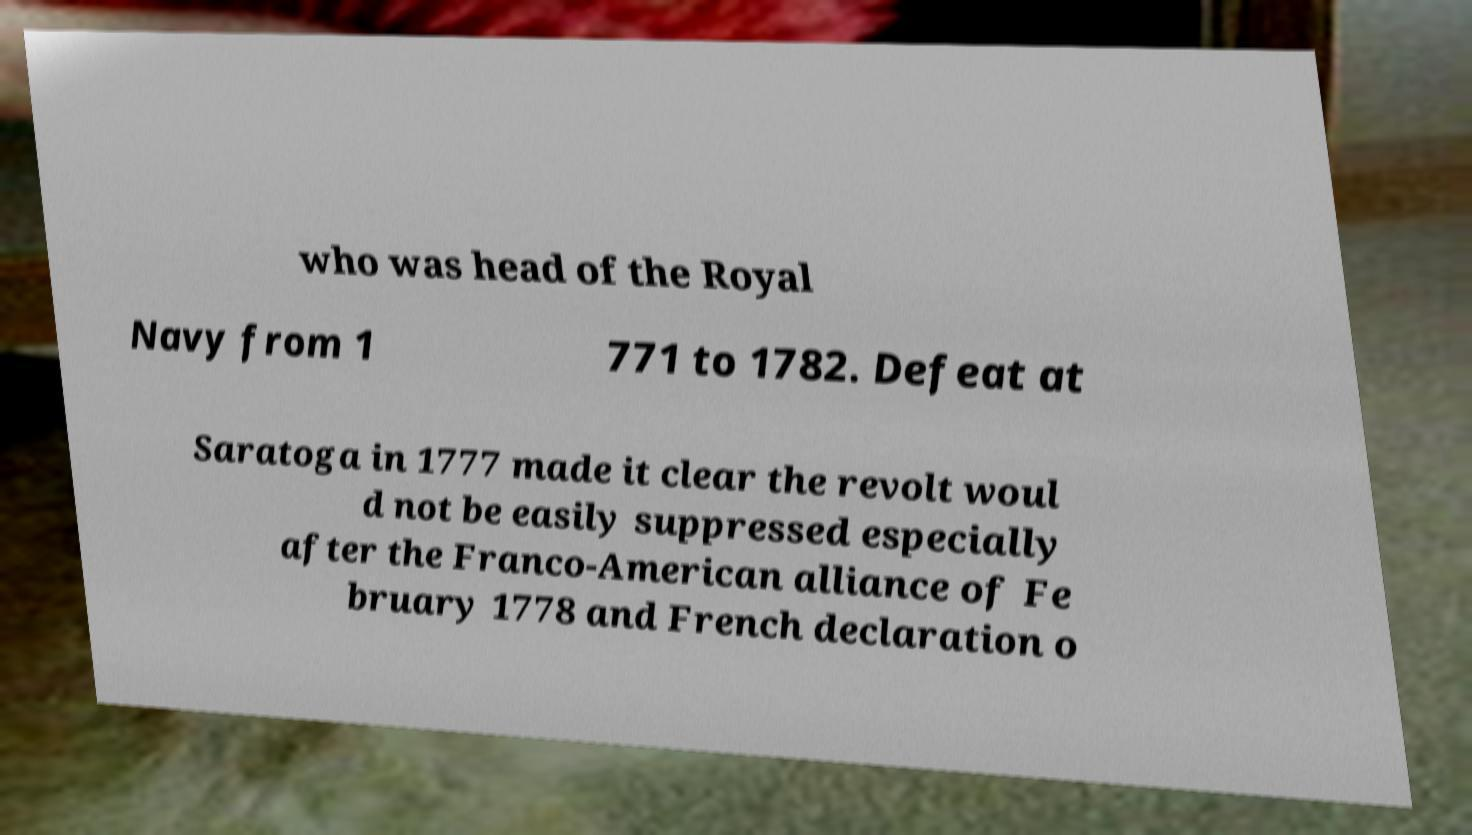Please identify and transcribe the text found in this image. who was head of the Royal Navy from 1 771 to 1782. Defeat at Saratoga in 1777 made it clear the revolt woul d not be easily suppressed especially after the Franco-American alliance of Fe bruary 1778 and French declaration o 